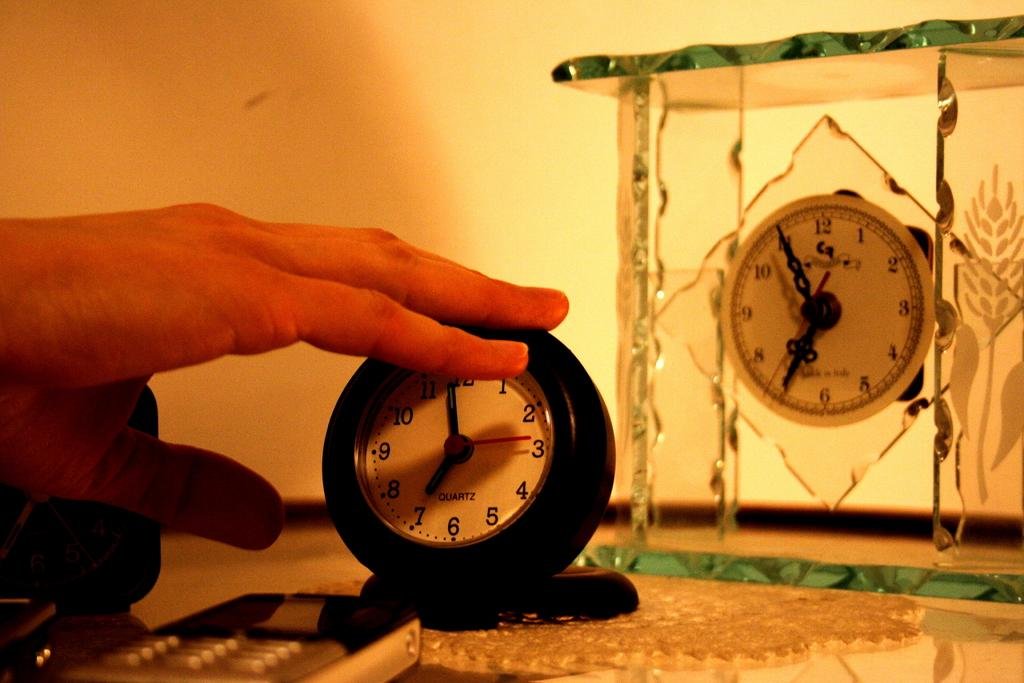Provide a one-sentence caption for the provided image. a clock with 1 thru 12 on the front of it. 